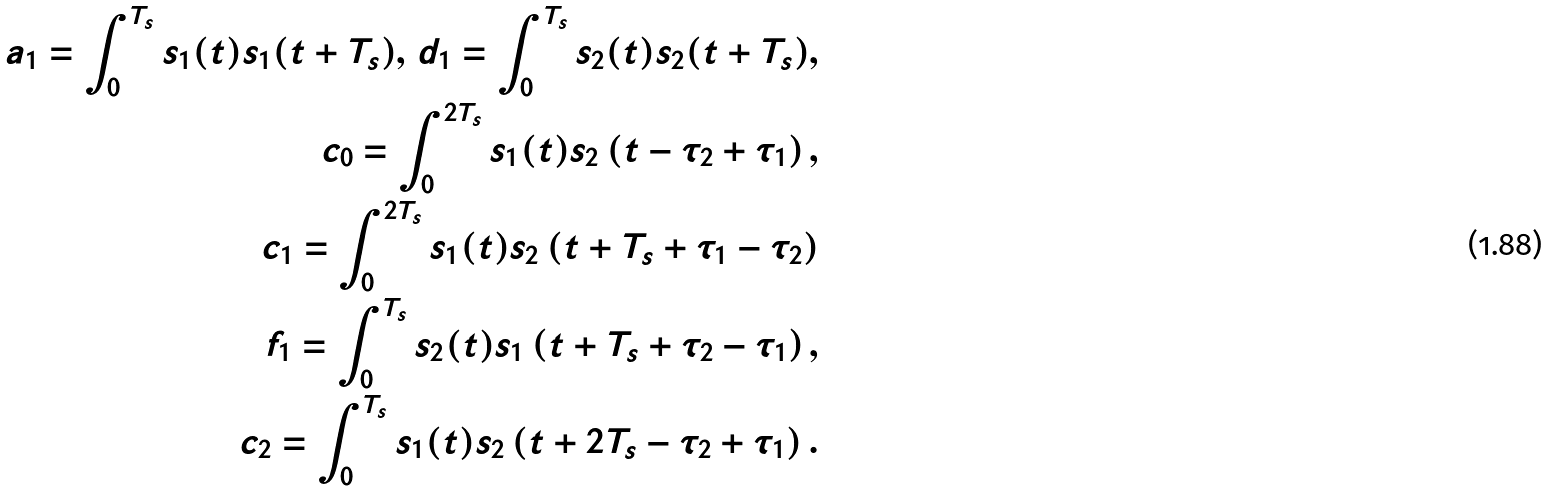<formula> <loc_0><loc_0><loc_500><loc_500>a _ { 1 } = \int _ { 0 } ^ { T _ { s } } s _ { 1 } ( t ) s _ { 1 } ( t + T _ { s } ) , \, d _ { 1 } = \int _ { 0 } ^ { T _ { s } } s _ { 2 } ( t ) s _ { 2 } ( t + T _ { s } ) , \\ c _ { 0 } = \int _ { 0 } ^ { 2 T _ { s } } s _ { 1 } ( t ) s _ { 2 } \left ( t - \tau _ { 2 } + \tau _ { 1 } \right ) , \\ c _ { 1 } = \int _ { 0 } ^ { 2 T _ { s } } s _ { 1 } ( t ) s _ { 2 } \left ( t + T _ { s } + \tau _ { 1 } - \tau _ { 2 } \right ) \\ f _ { 1 } = \int _ { 0 } ^ { T _ { s } } s _ { 2 } ( t ) s _ { 1 } \left ( t + T _ { s } + \tau _ { 2 } - \tau _ { 1 } \right ) , \\ c _ { 2 } = \int _ { 0 } ^ { T _ { s } } s _ { 1 } ( t ) s _ { 2 } \left ( t + 2 T _ { s } - \tau _ { 2 } + \tau _ { 1 } \right ) .</formula> 